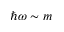<formula> <loc_0><loc_0><loc_500><loc_500>\hbar { \omega } \sim m</formula> 